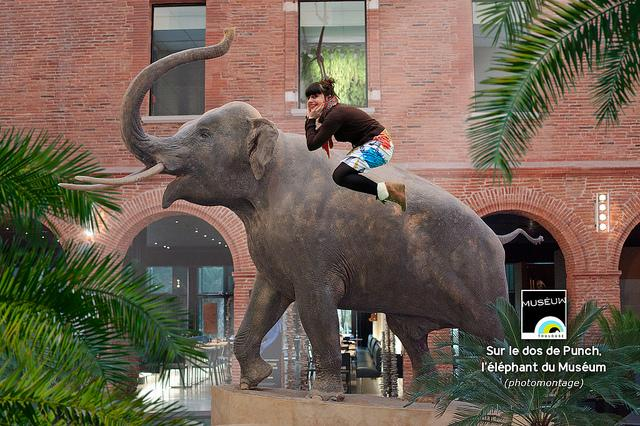What happened to this image? photoshopped 